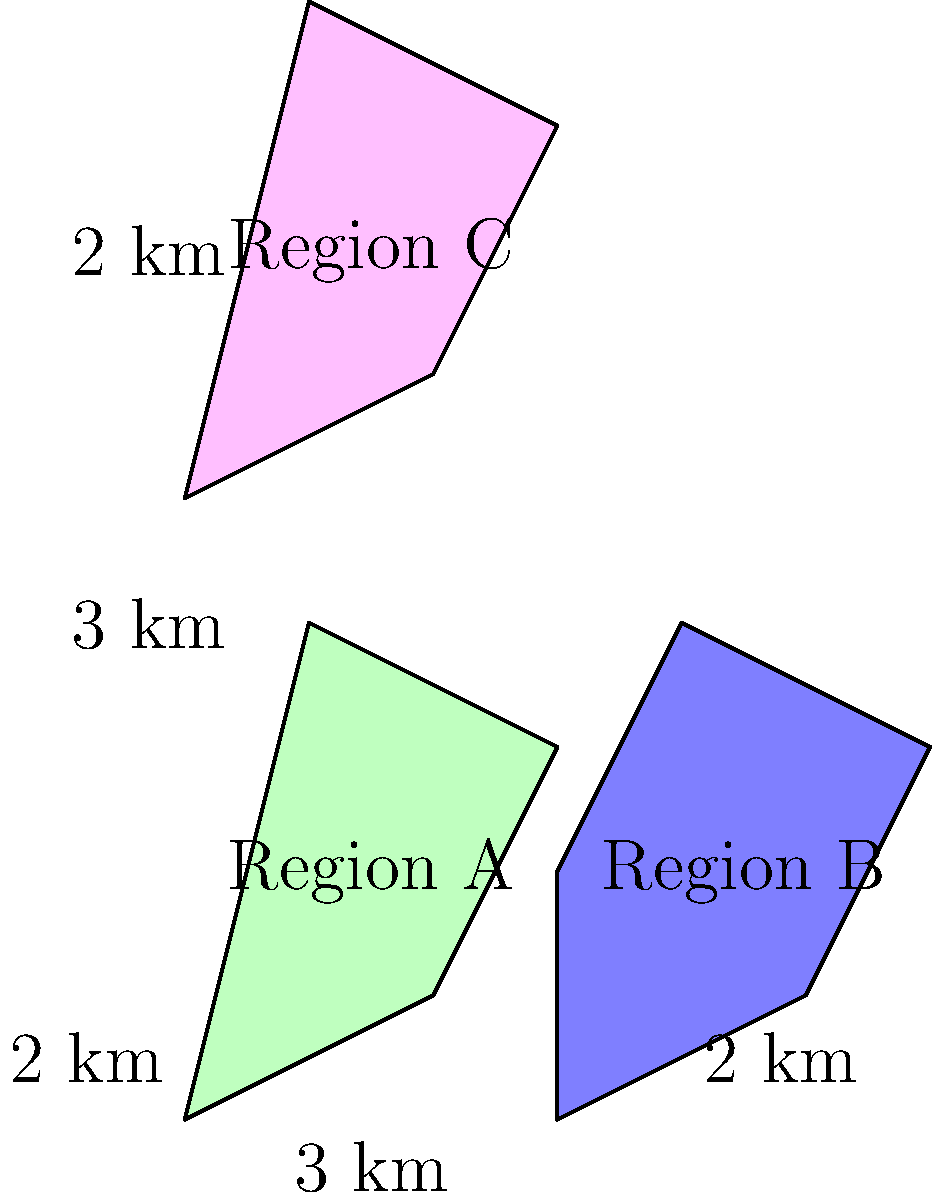A financial inclusion map represents three regions (A, B, and C) with varying levels of access to financial services. Each unit on the map represents 1 km. Given that Region A has an area of 5 km², calculate the total area of financial inclusion coverage for all three regions combined. To solve this problem, we need to calculate the areas of Regions B and C, then add them to the given area of Region A. Let's approach this step-by-step:

1. We're given that Region A has an area of 5 km².

2. For Region B:
   - It's an irregular pentagon, but we can approximate it as a trapezoid.
   - The parallel sides are roughly 2 km and 3 km (bottom and top).
   - The height is about 4 km.
   - Area of a trapezoid = $\frac{1}{2}(a+b)h$
   - Area of B ≈ $\frac{1}{2}(2+3) \times 4 = \frac{5}{2} \times 4 = 10$ km²

3. For Region C:
   - It's similar in shape to Region A.
   - Given that A is 5 km² and C looks about 3/4 the size of A.
   - Area of C ≈ $\frac{3}{4} \times 5 = 3.75$ km²

4. Total area of financial inclusion:
   $$ \text{Total Area} = \text{Area A} + \text{Area B} + \text{Area C} $$
   $$ \text{Total Area} = 5 + 10 + 3.75 = 18.75 \text{ km²} $$

Therefore, the total area of financial inclusion coverage for all three regions combined is approximately 18.75 km².
Answer: 18.75 km² 